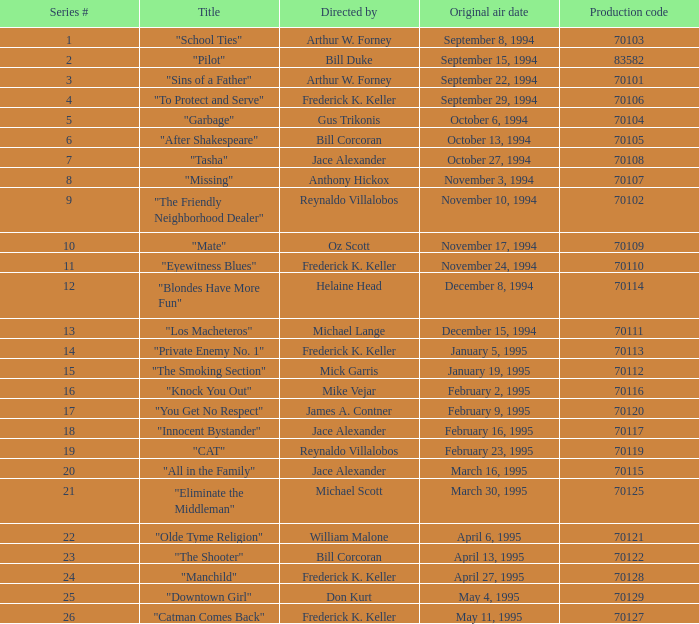Which production code value was the lowest in the 10th series? 70109.0. 